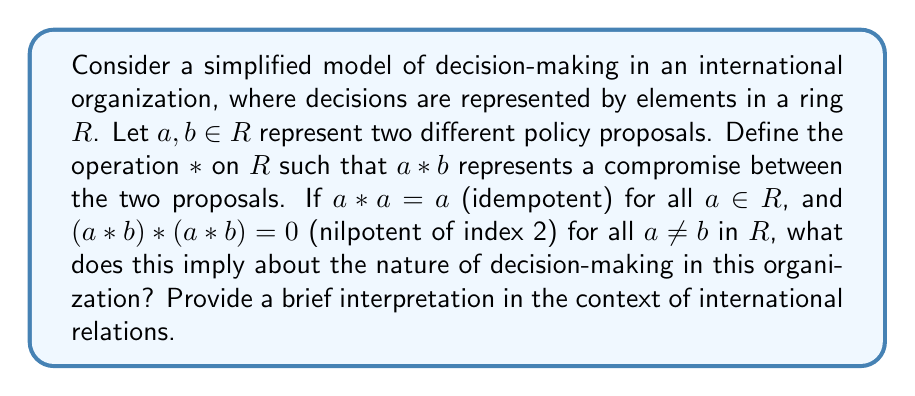Can you answer this question? To understand the implications of this ring structure on decision-making in international organizations, let's analyze the properties of idempotent and nilpotent elements:

1. Idempotent elements: $a * a = a$ for all $a \in R$
   This property suggests that when a single policy proposal is considered repeatedly, it remains unchanged. In the context of international relations, this could represent the stability of individual policy positions when not influenced by other proposals.

2. Nilpotent elements: $(a * b) * (a * b) = 0$ for all $a \neq b$ in $R$
   This property indicates that when two different policy proposals are combined (compromised) and then that compromise is applied again, the result is null (0). In international relations, this could represent the instability or unsustainability of compromises between differing policy positions.

Interpreting these properties in the context of decision-making in international organizations:

a) The idempotent property suggests that individual policy proposals are stable and self-reinforcing. This could represent the tendency of member states or factions within the organization to maintain their initial positions when not engaged in negotiation.

b) The nilpotent property of compromises implies that attempts to find middle ground between differing proposals are inherently unstable. When compromises are iteratively applied, they quickly lose their effectiveness, potentially leading to deadlock or the need for constant renegotiation.

c) The combination of these properties suggests a decision-making environment where:
   - Individual positions are entrenched and resistant to change.
   - Compromises are short-lived and do not lead to stable long-term solutions.
   - The organization may struggle to find lasting agreements on contentious issues.

This mathematical model reflects some of the challenges faced by international organizations in real-world conflict resolution scenarios, where competing interests and the difficulty of maintaining compromises can hinder effective decision-making.
Answer: The ring structure implies a decision-making process in the international organization characterized by:
1. Stable individual policy positions (idempotent elements)
2. Unstable compromises between differing positions (nilpotent elements)
3. Difficulty in achieving lasting agreements on contentious issues
This model reflects the challenges of balancing diverse interests and maintaining effective compromises in international conflict resolution efforts. 